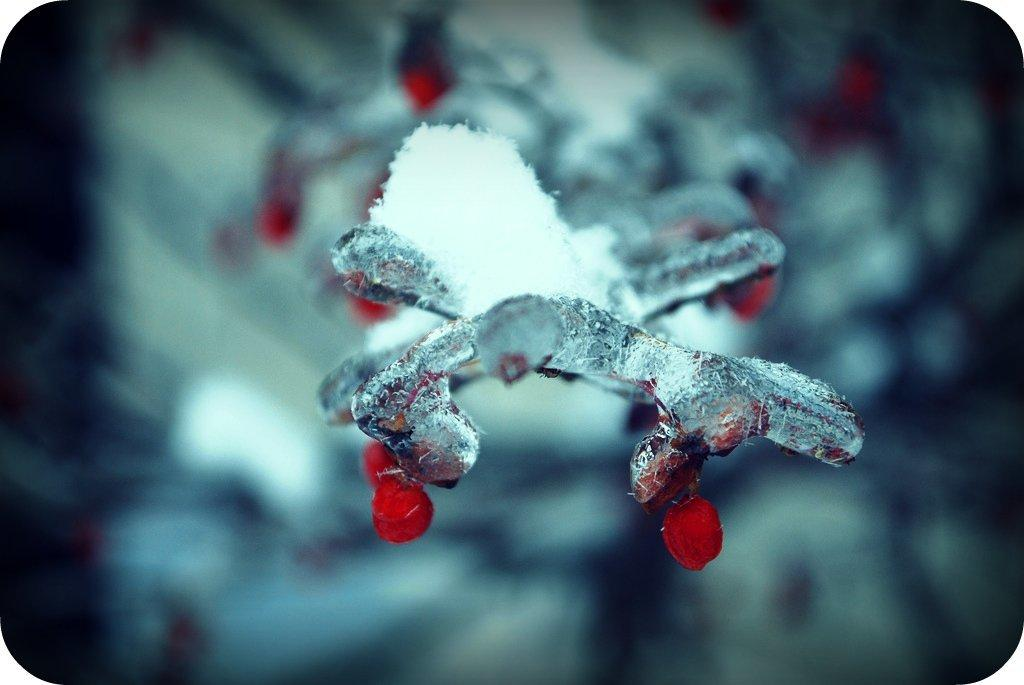What part of the image is clear and easy to see? The front of the image is in focus. What part of the image is difficult to see or blurry? The background of the image is blurred. How many lines can be seen in the image? There is no information about lines in the image, so it cannot be determined from the provided facts. What is the grandfather doing in the image? There is no mention of a grandfather or any person in the image, so it cannot be determined from the provided facts. 